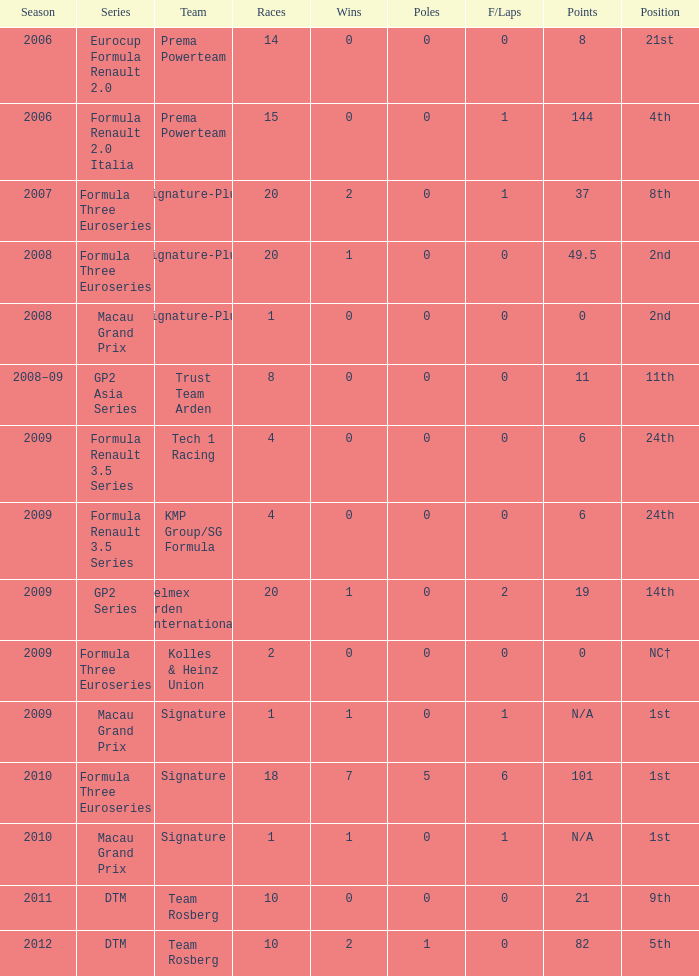In which set can you find 11 items? GP2 Asia Series. 